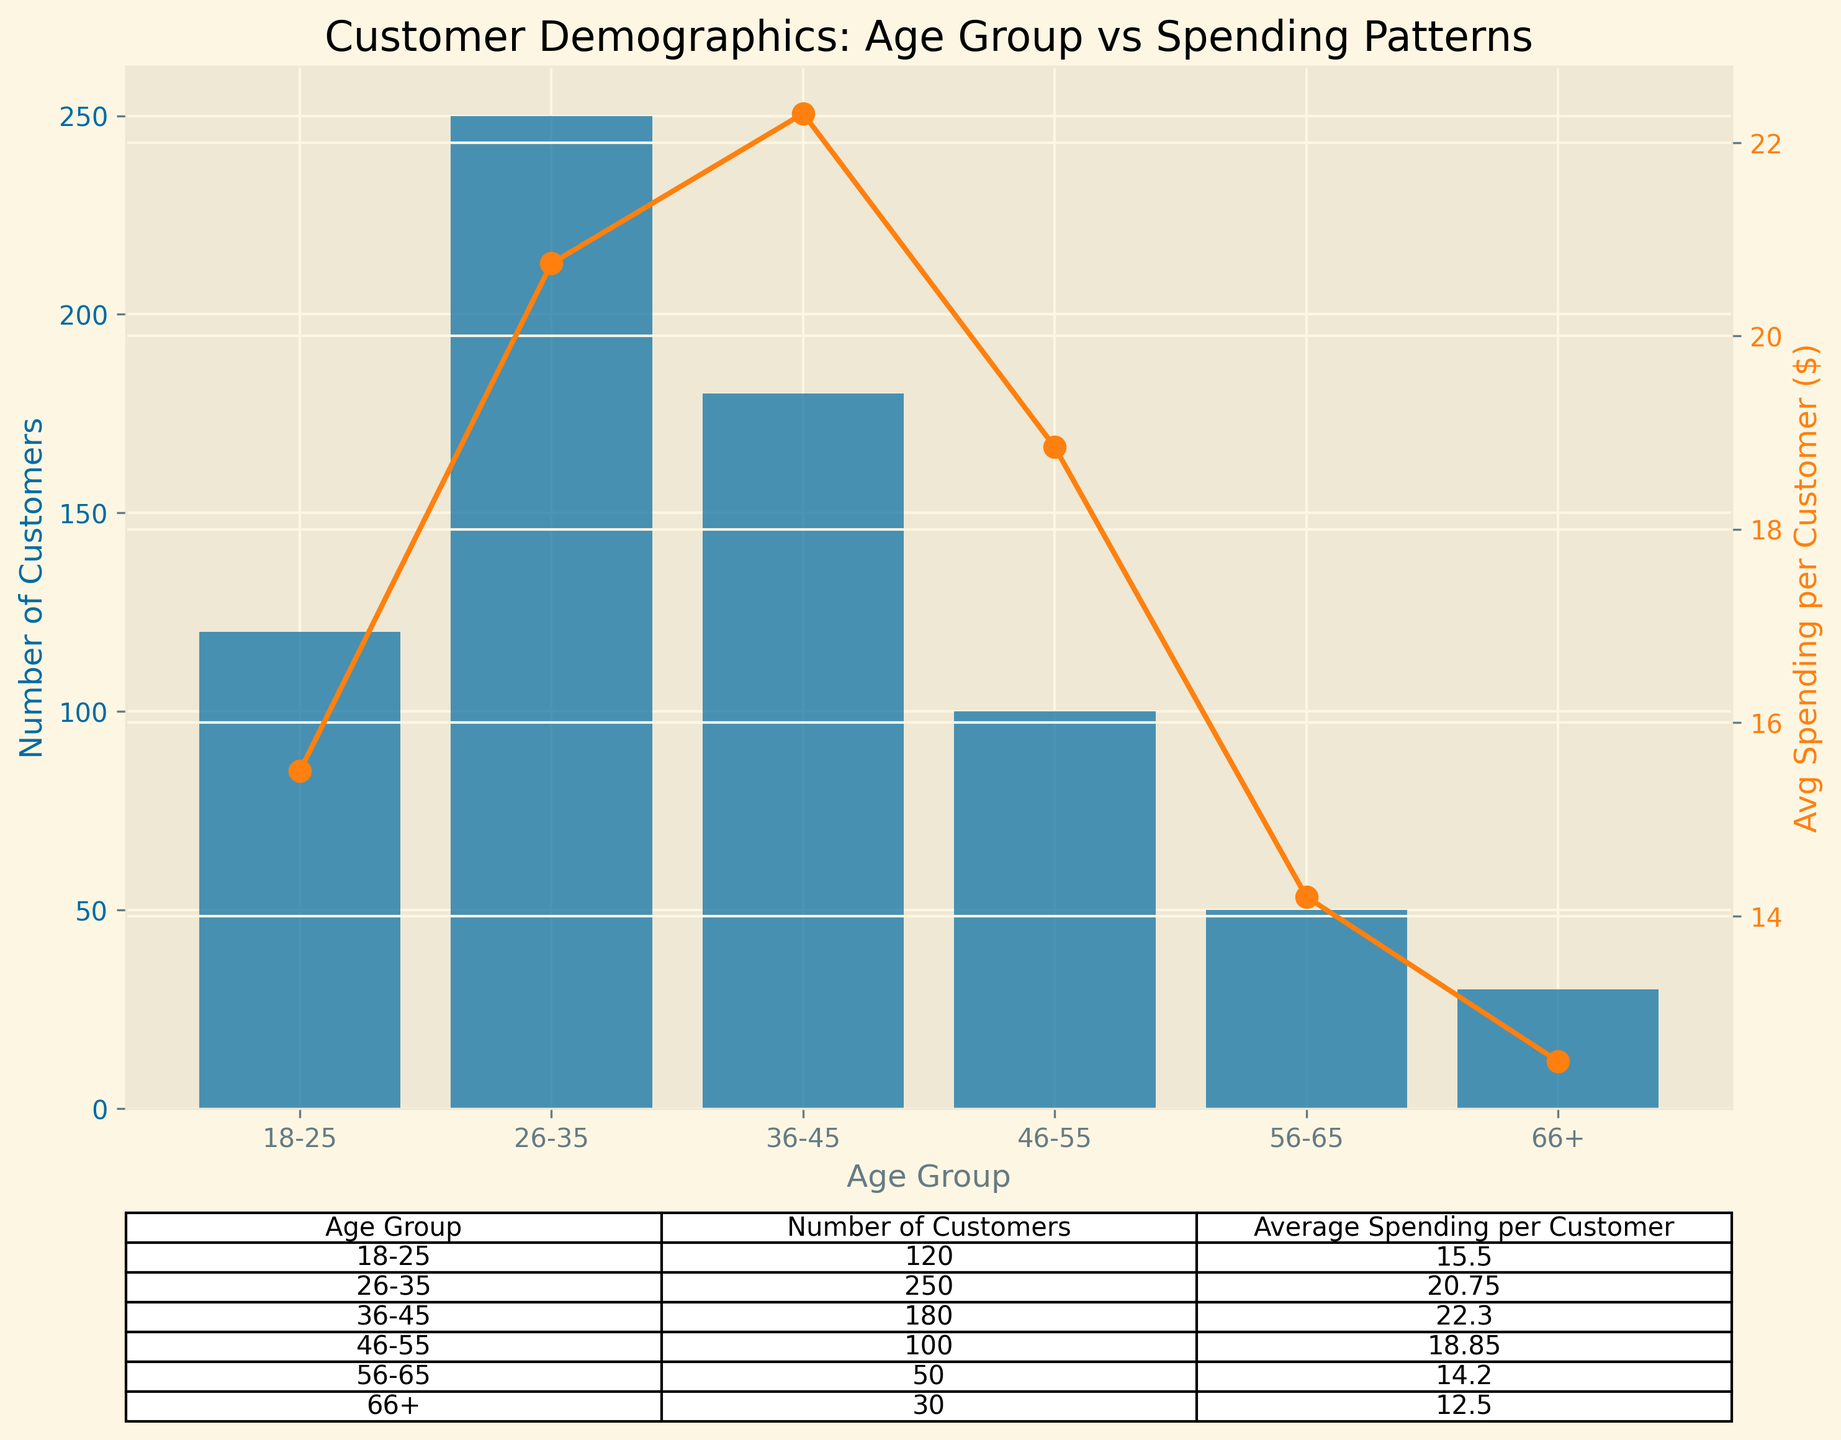What's the age group with the highest number of customers? The highest bar corresponds to the age group 26-35. This indicates that this age group has the most number of customers.
Answer: 26-35 Which age group has the lowest average spending per customer? The line plot shows that the average spending per customer is lowest for the age group 66+.
Answer: 66+ What is the combined total number of customers for age groups 18-25 and 36-45? The age group 18-25 has 120 customers and the age group 36-45 has 180 customers. Adding these together: 120 + 180 = 300
Answer: 300 How much higher is the average spending per customer in the 36-45 age group compared to the 18-25 age group? The average spending per customer for 36-45 is $22.30 and for 18-25 is $15.50. The difference is $22.30 - $15.50 = $6.80
Answer: $6.80 Which age group shows a visible decline in average spending per customer compared to the age group just before it? The line plot shows a decline in the average spending per customer from the 36-45 age group to the 46-55 age group.
Answer: 46-55 What is the total average spending for all customers in the 26-35 age group? There are 250 customers in the 26-35 age group, each spending an average of $20.75. Thus, the total spending is 250 * $20.75 = $5187.50
Answer: $5187.50 Which age group has a higher average spending per customer, 46-55 or 56-65? The line plot shows that the age group 46-55 has an average spending of $18.85, while the age group 56-65 has an average spending of $14.20. Hence, 46-55 has a higher average spending.
Answer: 46-55 Comparing the number of customers, is the 26-35 age group more than double that of the 36-45 age group? The 26-35 age group has 250 customers, and the 36-45 age group has 180 customers. Check if 250 > 2 * 180: 250 > 360 is false.
Answer: No What is the approximate difference in the average spending per customer between the age groups 26-35 and 56-65? The average spending per customer for 26-35 is $20.75 and for 56-65 is $14.20. The difference is $20.75 - $14.20 = $6.55
Answer: $6.55 